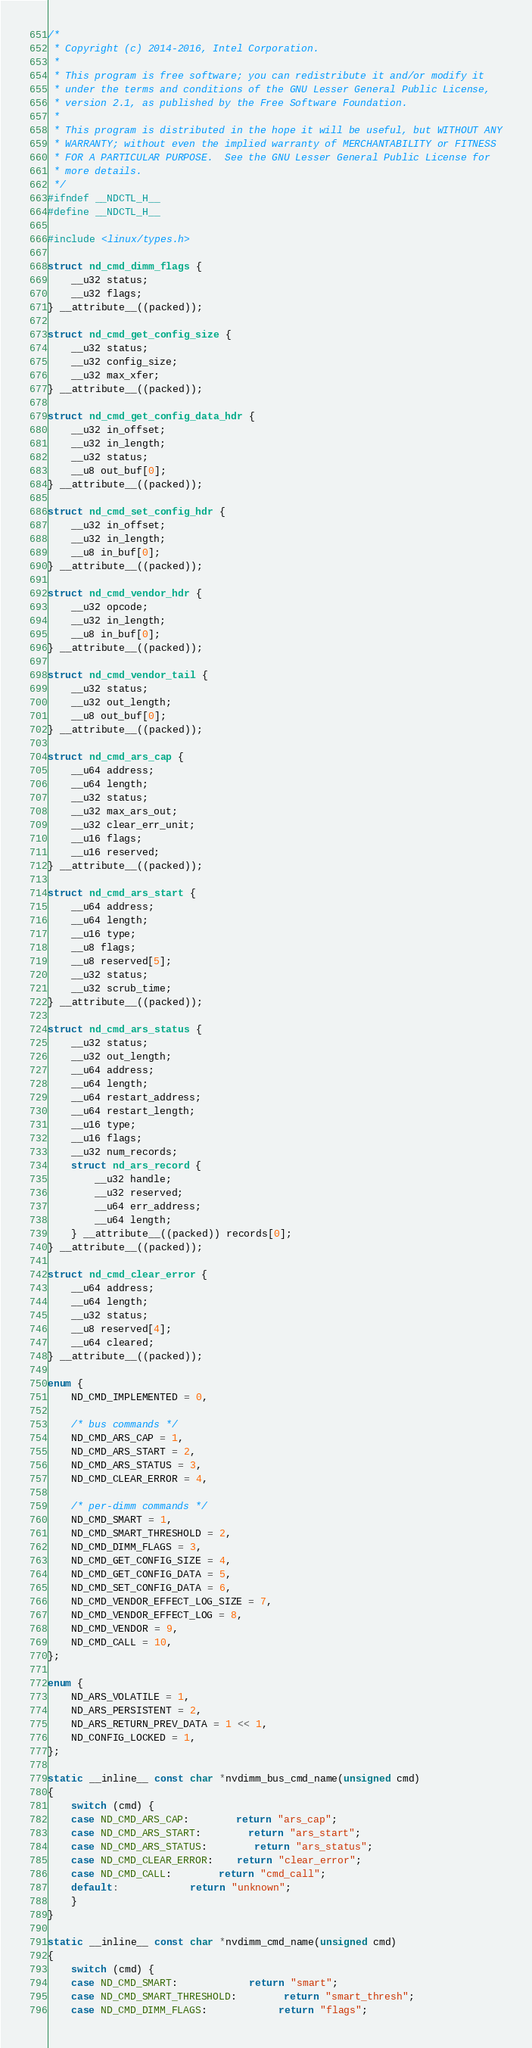Convert code to text. <code><loc_0><loc_0><loc_500><loc_500><_C_>/*
 * Copyright (c) 2014-2016, Intel Corporation.
 *
 * This program is free software; you can redistribute it and/or modify it
 * under the terms and conditions of the GNU Lesser General Public License,
 * version 2.1, as published by the Free Software Foundation.
 *
 * This program is distributed in the hope it will be useful, but WITHOUT ANY
 * WARRANTY; without even the implied warranty of MERCHANTABILITY or FITNESS
 * FOR A PARTICULAR PURPOSE.  See the GNU Lesser General Public License for
 * more details.
 */
#ifndef __NDCTL_H__
#define __NDCTL_H__

#include <linux/types.h>

struct nd_cmd_dimm_flags {
	__u32 status;
	__u32 flags;
} __attribute__((packed));

struct nd_cmd_get_config_size {
	__u32 status;
	__u32 config_size;
	__u32 max_xfer;
} __attribute__((packed));

struct nd_cmd_get_config_data_hdr {
	__u32 in_offset;
	__u32 in_length;
	__u32 status;
	__u8 out_buf[0];
} __attribute__((packed));

struct nd_cmd_set_config_hdr {
	__u32 in_offset;
	__u32 in_length;
	__u8 in_buf[0];
} __attribute__((packed));

struct nd_cmd_vendor_hdr {
	__u32 opcode;
	__u32 in_length;
	__u8 in_buf[0];
} __attribute__((packed));

struct nd_cmd_vendor_tail {
	__u32 status;
	__u32 out_length;
	__u8 out_buf[0];
} __attribute__((packed));

struct nd_cmd_ars_cap {
	__u64 address;
	__u64 length;
	__u32 status;
	__u32 max_ars_out;
	__u32 clear_err_unit;
	__u16 flags;
	__u16 reserved;
} __attribute__((packed));

struct nd_cmd_ars_start {
	__u64 address;
	__u64 length;
	__u16 type;
	__u8 flags;
	__u8 reserved[5];
	__u32 status;
	__u32 scrub_time;
} __attribute__((packed));

struct nd_cmd_ars_status {
	__u32 status;
	__u32 out_length;
	__u64 address;
	__u64 length;
	__u64 restart_address;
	__u64 restart_length;
	__u16 type;
	__u16 flags;
	__u32 num_records;
	struct nd_ars_record {
		__u32 handle;
		__u32 reserved;
		__u64 err_address;
		__u64 length;
	} __attribute__((packed)) records[0];
} __attribute__((packed));

struct nd_cmd_clear_error {
	__u64 address;
	__u64 length;
	__u32 status;
	__u8 reserved[4];
	__u64 cleared;
} __attribute__((packed));

enum {
	ND_CMD_IMPLEMENTED = 0,

	/* bus commands */
	ND_CMD_ARS_CAP = 1,
	ND_CMD_ARS_START = 2,
	ND_CMD_ARS_STATUS = 3,
	ND_CMD_CLEAR_ERROR = 4,

	/* per-dimm commands */
	ND_CMD_SMART = 1,
	ND_CMD_SMART_THRESHOLD = 2,
	ND_CMD_DIMM_FLAGS = 3,
	ND_CMD_GET_CONFIG_SIZE = 4,
	ND_CMD_GET_CONFIG_DATA = 5,
	ND_CMD_SET_CONFIG_DATA = 6,
	ND_CMD_VENDOR_EFFECT_LOG_SIZE = 7,
	ND_CMD_VENDOR_EFFECT_LOG = 8,
	ND_CMD_VENDOR = 9,
	ND_CMD_CALL = 10,
};

enum {
	ND_ARS_VOLATILE = 1,
	ND_ARS_PERSISTENT = 2,
	ND_ARS_RETURN_PREV_DATA = 1 << 1,
	ND_CONFIG_LOCKED = 1,
};

static __inline__ const char *nvdimm_bus_cmd_name(unsigned cmd)
{
	switch (cmd) {
	case ND_CMD_ARS_CAP:		return "ars_cap";
	case ND_CMD_ARS_START:		return "ars_start";
	case ND_CMD_ARS_STATUS:		return "ars_status";
	case ND_CMD_CLEAR_ERROR:	return "clear_error";
	case ND_CMD_CALL:		return "cmd_call";
	default:			return "unknown";
	}
}

static __inline__ const char *nvdimm_cmd_name(unsigned cmd)
{
	switch (cmd) {
	case ND_CMD_SMART:			return "smart";
	case ND_CMD_SMART_THRESHOLD:		return "smart_thresh";
	case ND_CMD_DIMM_FLAGS:			return "flags";</code> 